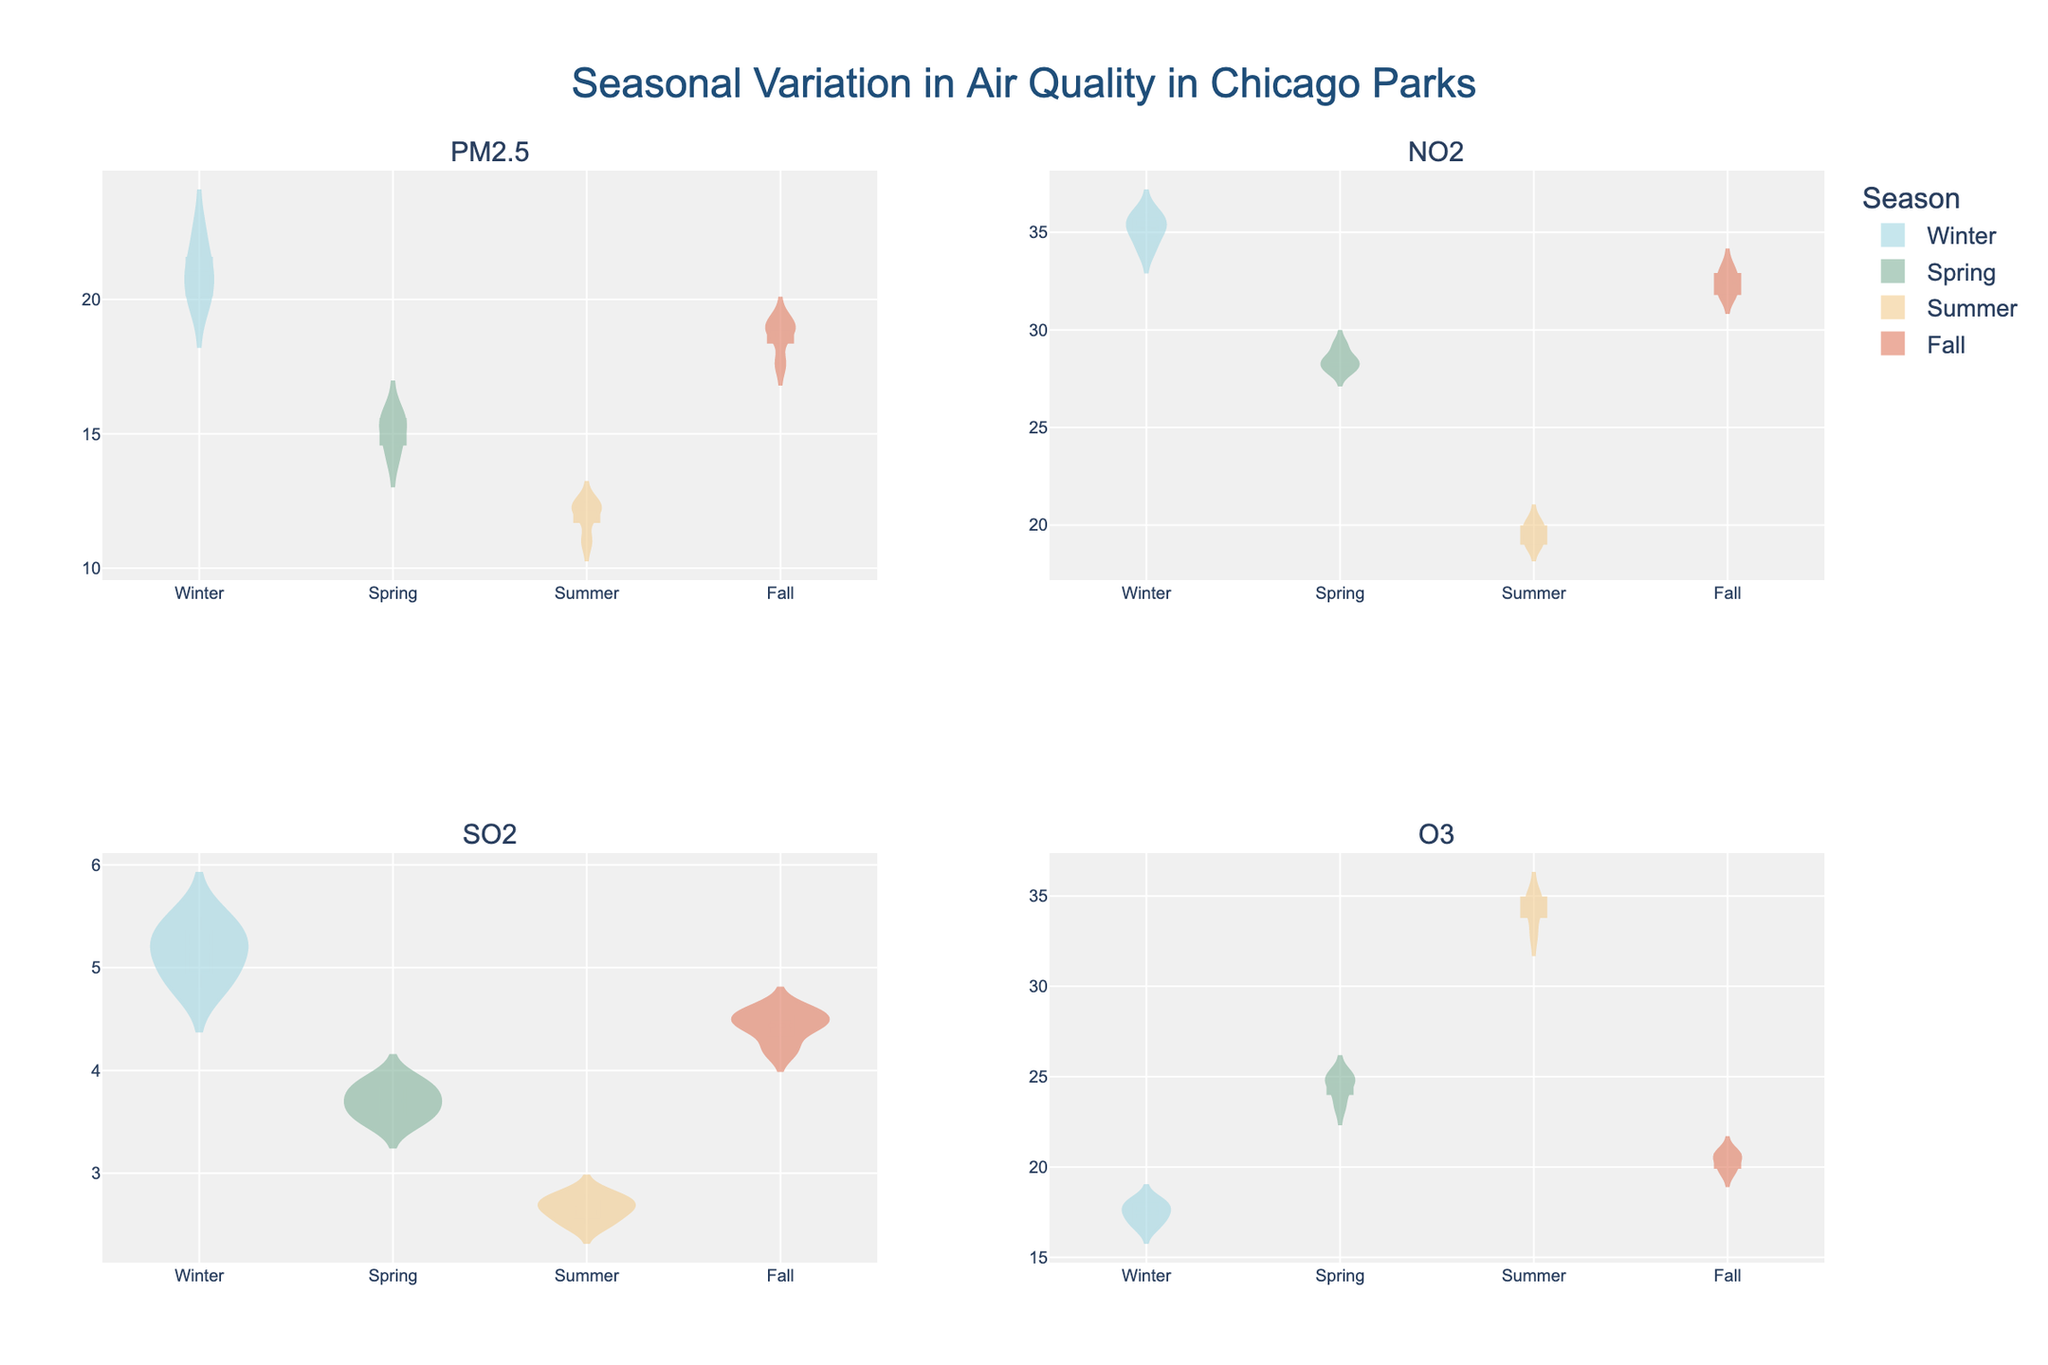What does the title of the chart say? The title is located at the top of the chart and provides a description of the data being visualized.
Answer: "Seasonal Variation in Air Quality in Chicago Parks" Which season has the highest levels of PM2.5? To determine the highest levels of PM2.5, look at the violin plots for PM2.5 and compare the heights of the violins for each season. The season with the highest violin is associated with the highest values.
Answer: Winter How do the median NO2 levels compare between Summer and Fall? Examine the middle line (median) within the violin plots for NO2 for both Summer and Fall. Compare the heights of these lines to see which is higher.
Answer: Higher in Fall What is the range of SO2 levels in Grant Park during Summer? Look at the width of the violin plot for SO2 in Summer corresponding to Grant Park. The range is the range of the y-axis values spanned by the plot.
Answer: 2.5 to 2.8 In which season is the variability of O3 levels the highest? Variability can be assessed by looking at the spread or width of the violin plot for O3 across the different seasons. The season with the widest spread has the highest variability.
Answer: Summer Compare the interquartile range of PM2.5 levels between Winter and Spring. The interquartile range (IQR) is the distance between the first and third quartiles. Examine the box within the violin plots for PM2.5 in Winter and Spring and compare the heights of these boxes.
Answer: Higher in Winter Which park has the most consistent (least variable) levels of NO2 during Spring? Consistency is assessed by finding the narrowest (least variability) part of the violin plots for NO2 during Spring across different parks.
Answer: Millennium Park Are the mean SO2 levels higher in Winter or Fall? The mean is indicated by the horizontal line within each violin plot. Compare the lines for SO2 in Winter and Fall plots.
Answer: Winter What can you infer about the seasonal variation in O3 levels in Chicago parks? O3 levels appear to peak in Summer and are relatively lower in the other seasons. This suggests O3 concentrations in parks are higher in the warmer months.
Answer: Peak in Summer, lower in other seasons How do PM2.5 levels vary between Millennium Park and Grant Park in Fall? Compare the heights of the violin plots for PM2.5 levels in Millennium Park and Grant Park during Fall.
Answer: Higher in Grant Park 